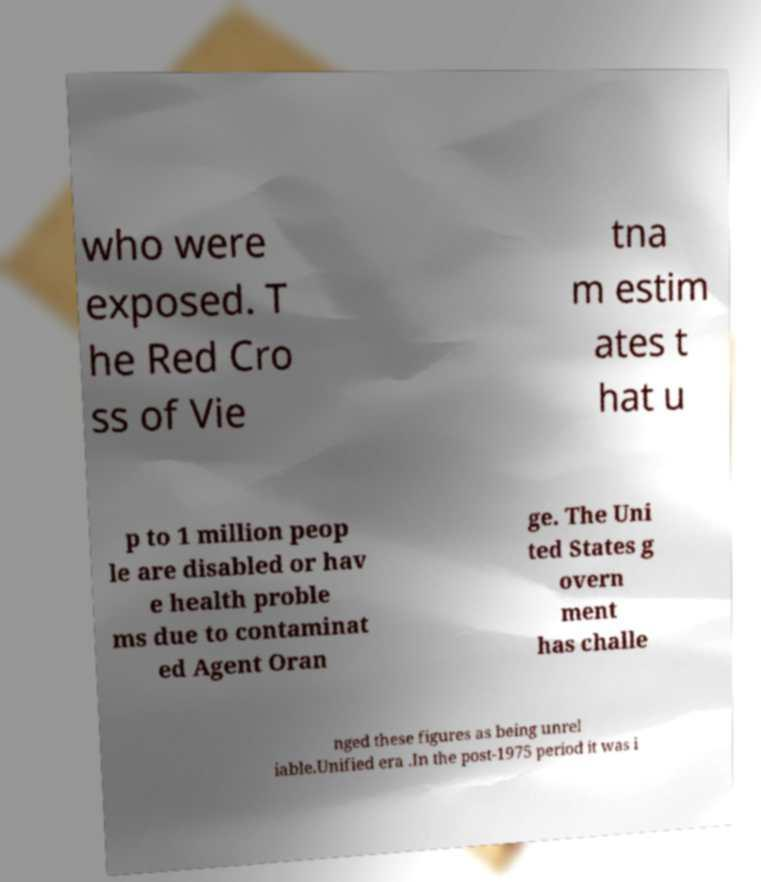Could you extract and type out the text from this image? who were exposed. T he Red Cro ss of Vie tna m estim ates t hat u p to 1 million peop le are disabled or hav e health proble ms due to contaminat ed Agent Oran ge. The Uni ted States g overn ment has challe nged these figures as being unrel iable.Unified era .In the post-1975 period it was i 